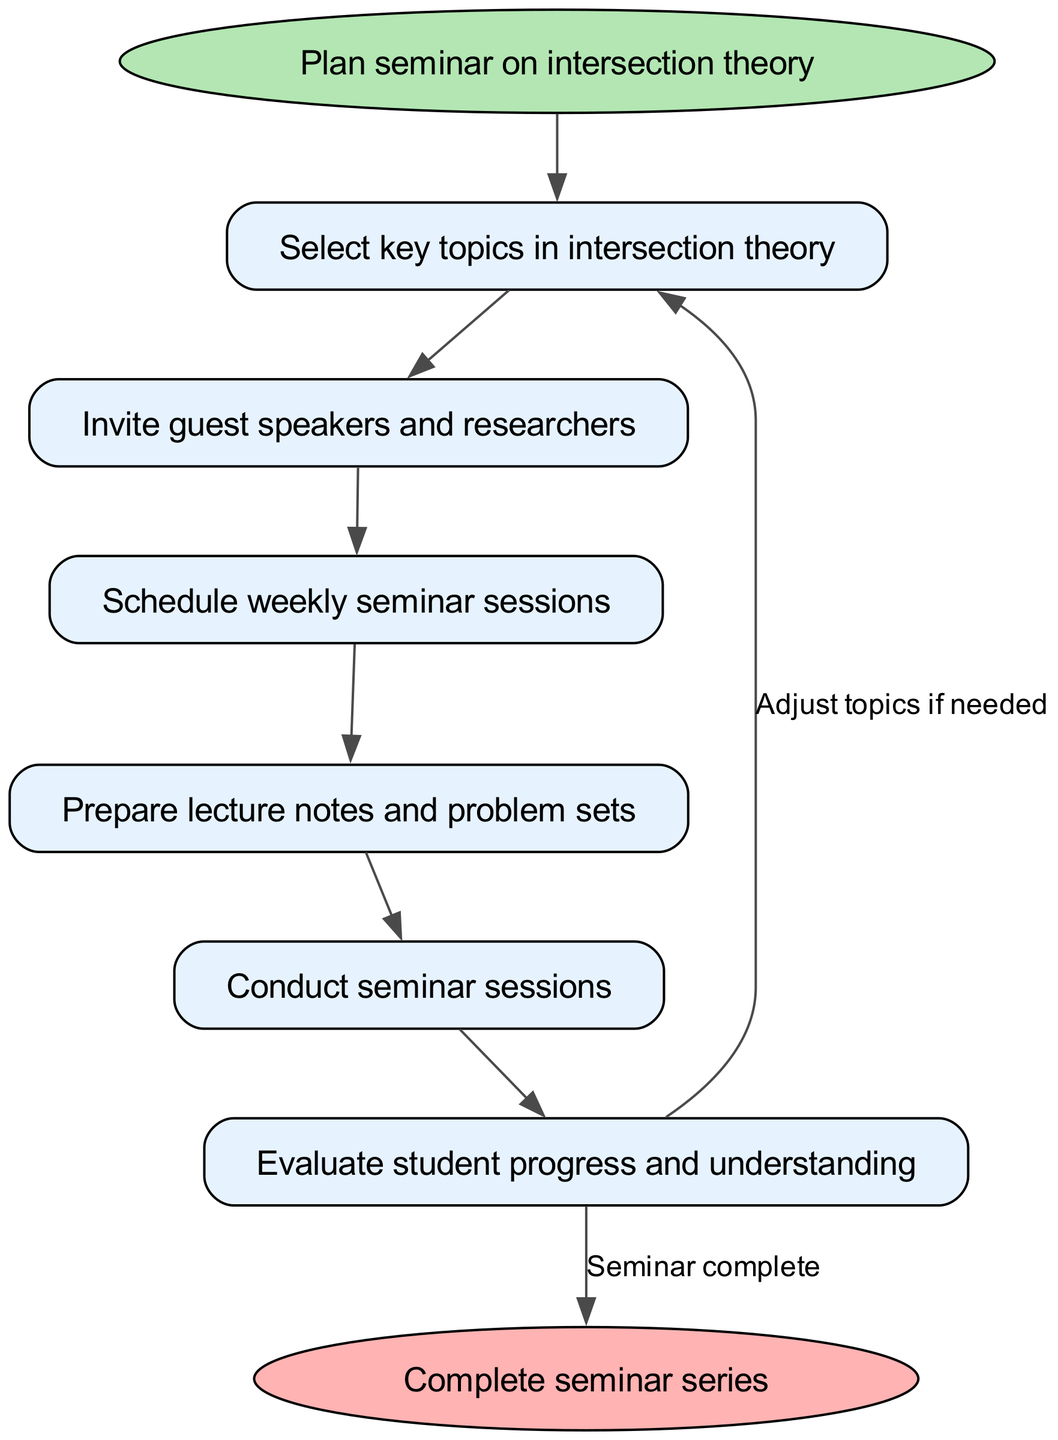What is the starting point of the seminar workflow? The diagram begins with the node labeled "Plan seminar on intersection theory," indicating this step as the initiating action.
Answer: Plan seminar on intersection theory How many main nodes are there in the diagram? There are six main nodes representing key activities in the seminar workflow. These are: select topics, invite speakers, schedule sessions, prepare materials, conduct seminar, and evaluate progress.
Answer: Six Which node comes after "invite guest speakers and researchers"? The flowchart directs from the "invite speakers" node to the "schedule sessions" node, indicating that scheduling occurs after inviting speakers.
Answer: Schedule weekly seminar sessions What action follows the "conduct seminar sessions"? The next step after conducting seminar sessions is "evaluate student progress and understanding," as shown in the flow from conduct seminar to evaluate progress.
Answer: Evaluate student progress and understanding If adjustments are needed after evaluating progress, which node would be revisited? The diagram indicates a feedback loop where "evaluate progress" leads back to "select key topics," suggesting topics may be adjusted based on evaluations.
Answer: Select key topics How does the diagram depict the completion of the seminar series? The completion is visualized with an edge from the "evaluate progress" node that leads to the "Complete seminar series" endpoint, marking the end of the workflow.
Answer: Complete seminar series What color represents the start and end nodes in the diagram? The start node is colored light green, and the end node is colored light red, differentiating these critical points in the workflow.
Answer: Light green and light red Which node is first to require materials preparation? The "prepare materials" node is the first specific stage that involves creating resources for the seminar after scheduling the sessions.
Answer: Prepare lecture notes and problem sets 